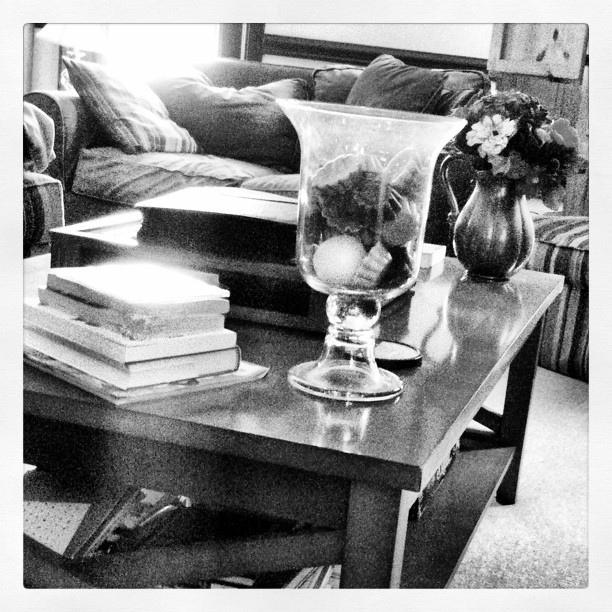What room of the house is this?
Give a very brief answer. Living room. Do the decorations here indicate wealth?
Short answer required. Yes. How many books are there on the table?
Concise answer only. 6. 